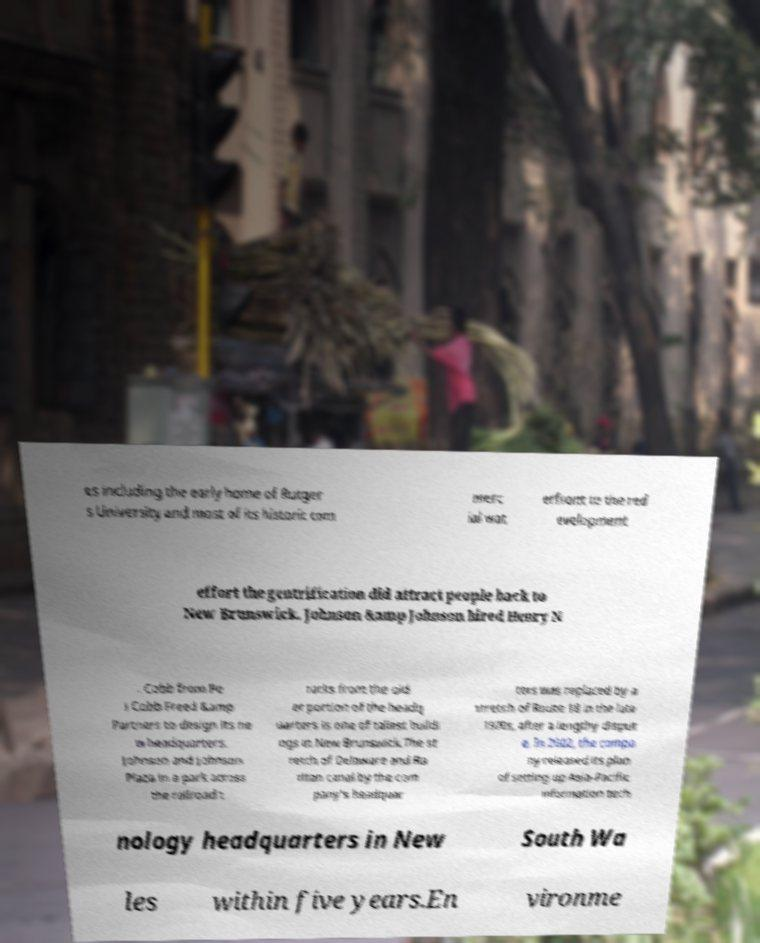What messages or text are displayed in this image? I need them in a readable, typed format. es including the early home of Rutger s University and most of its historic com merc ial wat erfront to the red evelopment effort the gentrification did attract people back to New Brunswick. Johnson &amp Johnson hired Henry N . Cobb from Pe i Cobb Freed &amp Partners to design its ne w headquarters. Johnson and Johnson Plaza in a park across the railroad t racks from the old er portion of the headq uarters is one of tallest buildi ngs in New Brunswick.The st retch of Delaware and Ra ritan canal by the com pany's headquar ters was replaced by a stretch of Route 18 in the late 1970s, after a lengthy disput e. In 2002, the compa ny released its plan of setting up Asia-Pacific information tech nology headquarters in New South Wa les within five years.En vironme 